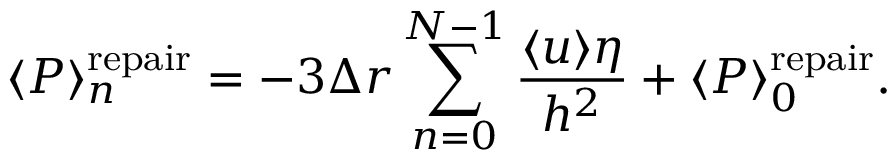<formula> <loc_0><loc_0><loc_500><loc_500>\langle P \rangle _ { n } ^ { r e p a i r } = - 3 \Delta r \sum _ { n = 0 } ^ { N - 1 } \frac { \langle u \rangle \eta } { h ^ { 2 } } + \langle P \rangle _ { 0 } ^ { r e p a i r } .</formula> 